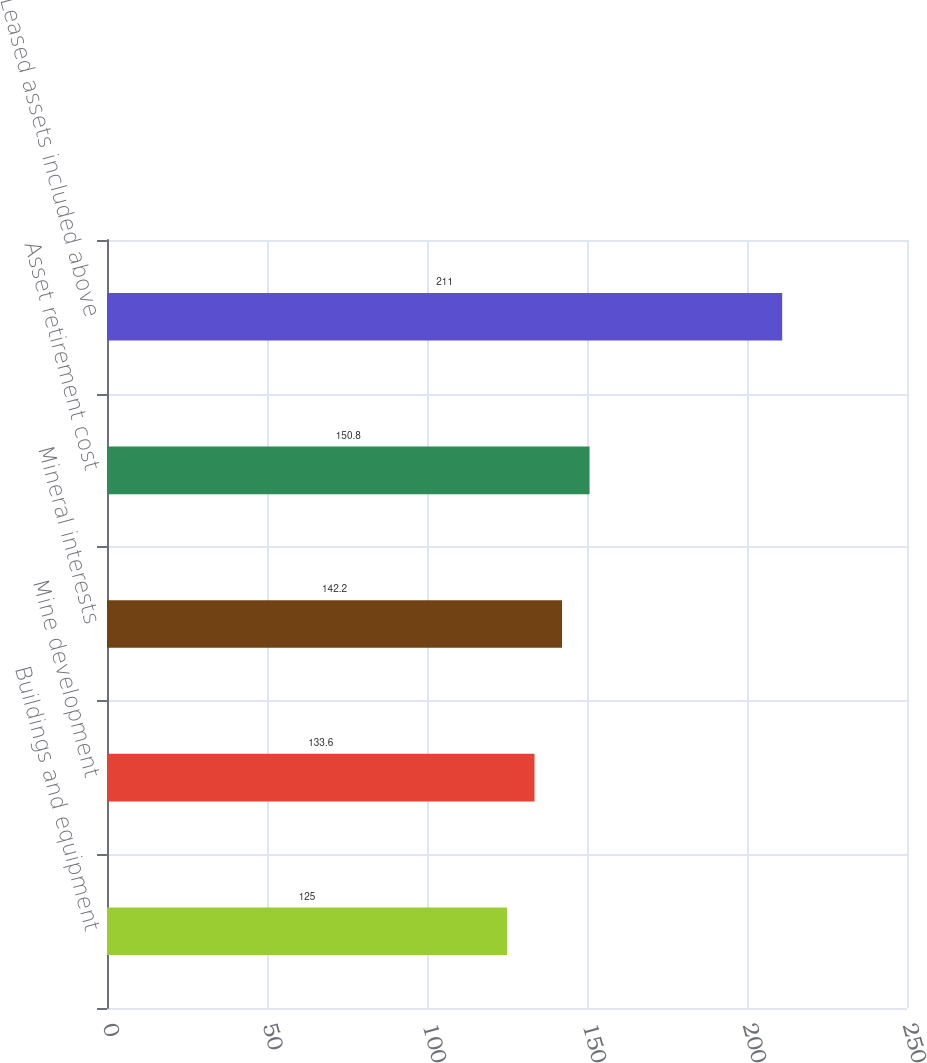<chart> <loc_0><loc_0><loc_500><loc_500><bar_chart><fcel>Buildings and equipment<fcel>Mine development<fcel>Mineral interests<fcel>Asset retirement cost<fcel>Leased assets included above<nl><fcel>125<fcel>133.6<fcel>142.2<fcel>150.8<fcel>211<nl></chart> 